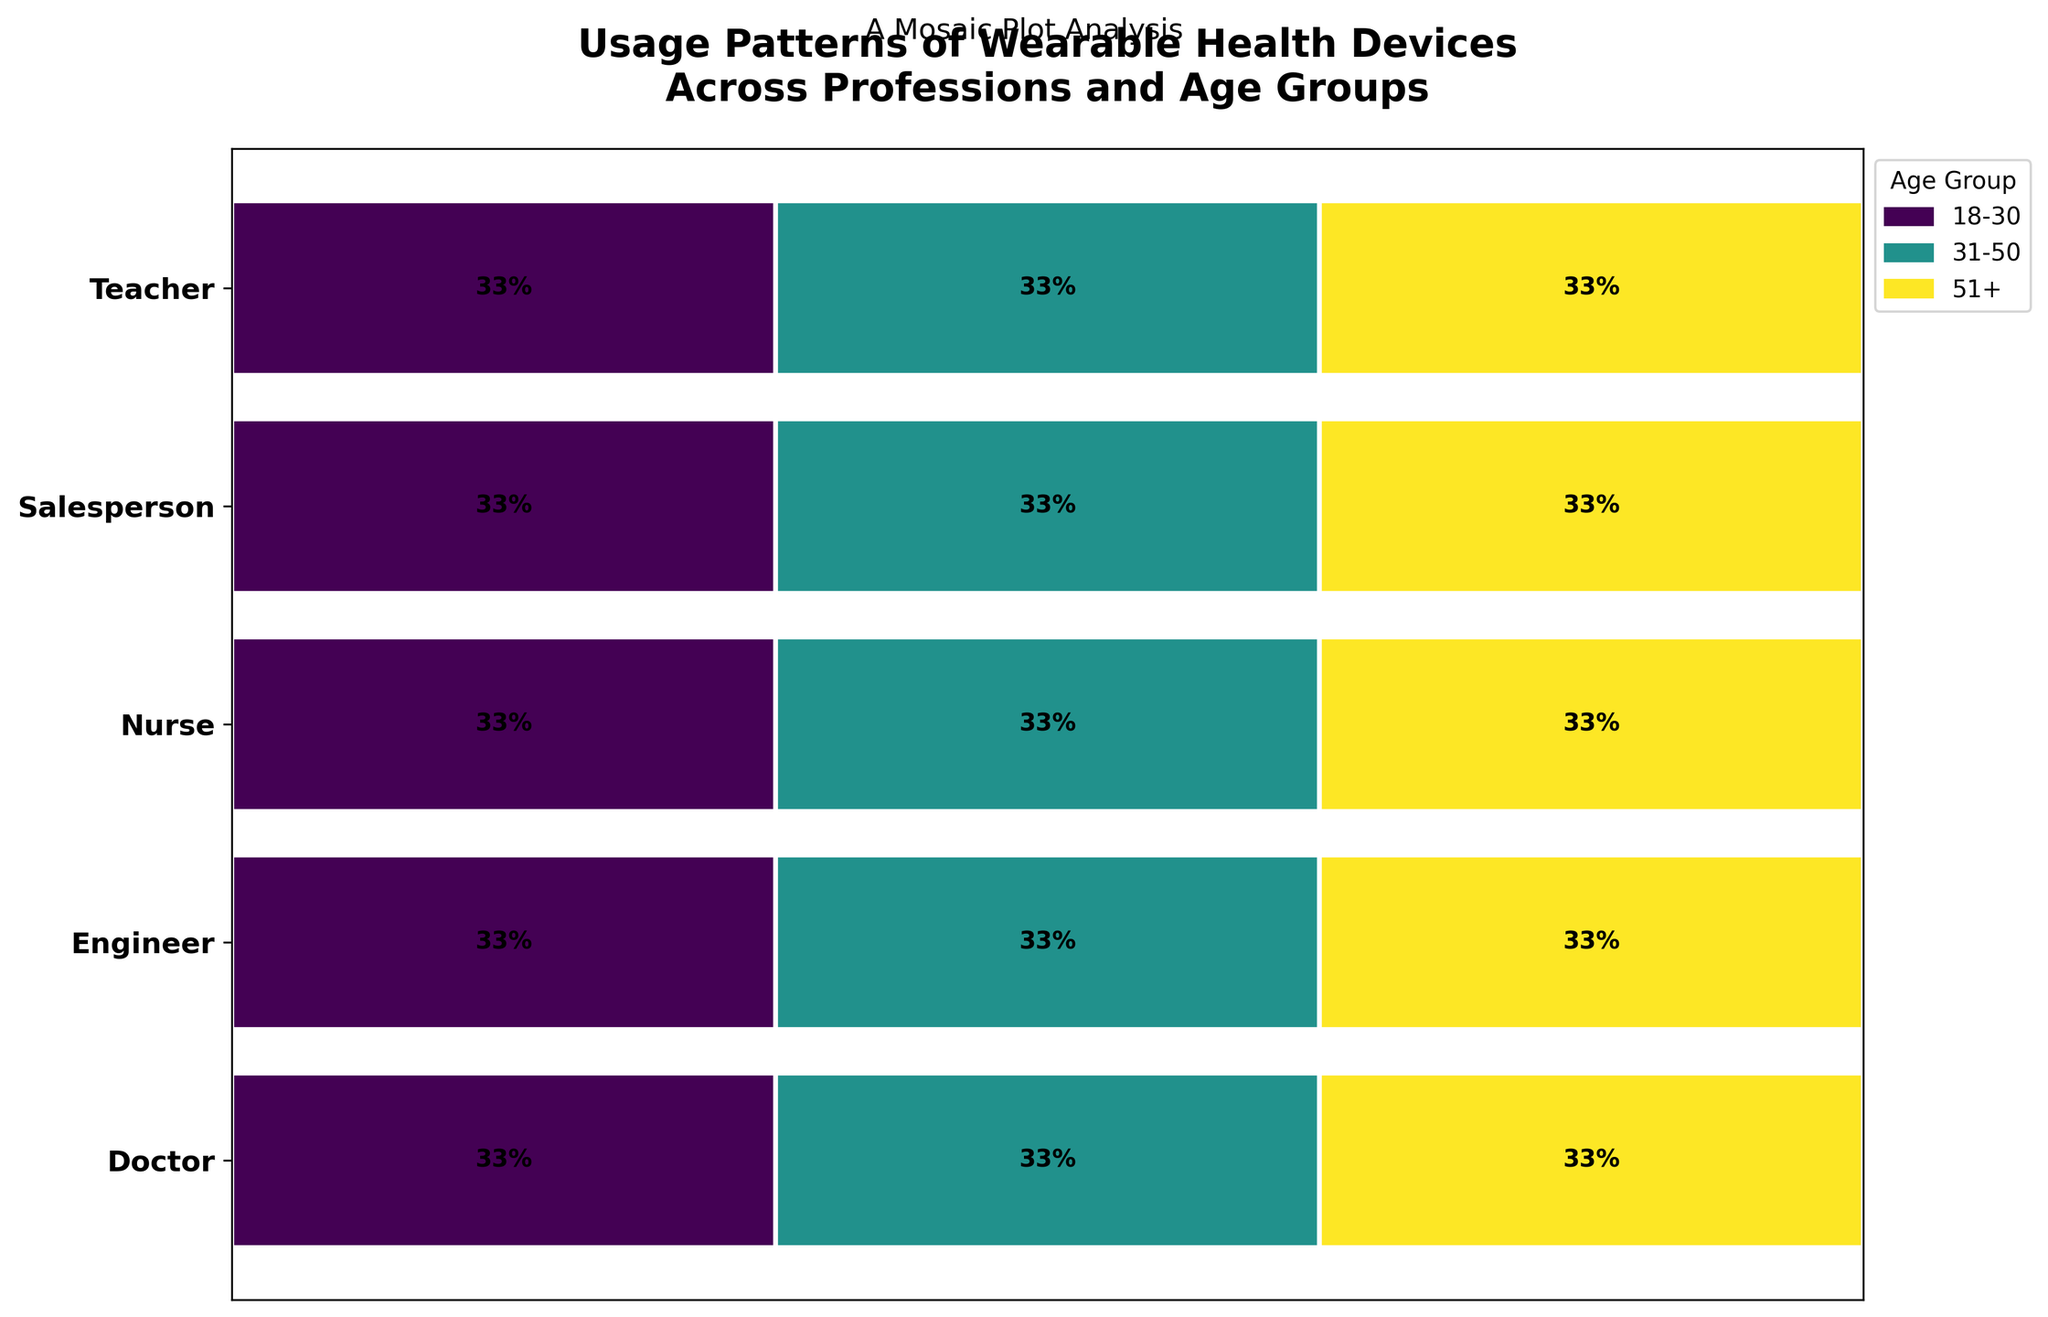What is the title of the plot? The title is usually positioned at the top of the figure and provides a summary of what the data visualization represents. For our plot, the title indicates the subject of the analysis.
Answer: Usage Patterns of Wearable Health Devices Across Professions and Age Groups Which profession has the highest usage in the 18-30 age group? Look at the section corresponding to the 18-30 age group in the mosaic plot and identify which profession has the largest segment.
Answer: Salesperson What percentage of nurses use devices daily across all age groups? Identify the segments labeled with the daily usage across all age groups for nurses and sum up the percentages shown within each group.
Answer: 100% Which age group uses wearable health devices the most in the "Engineer" profession? Compare the relative sizes of the segments for each age group within the "Engineer" profession. The largest segment indicates the age group with the most usage.
Answer: 18-30 Do doctors in the 31-50 age group use wearable devices more or less frequently than teachers in the same age group? Compare the segments for the 31-50 age group for both professions. Assess the frequency based on the label indications.
Answer: Less frequently Which age group shows the most diverse usage patterns across all professions? Assess the differences in segment sizes across all professions within each age group. The age group with the most varied segment sizes shows the most diverse usage patterns.
Answer: 31-50 What proportion of teachers in the 51+ age group use Smartwatches monthly? Look specifically at the segment corresponding to the 51+ age group for teachers and find the percentage labeled as monthly usage.
Answer: 100% How does the use of Blood Pressure Monitors differ between nurses and engineers in the 51+ age group? Examine the 51+ age group segments for both nurses and engineers and compare the relative sizes and frequencies of the Blood Pressure Monitor usage.
Answer: Nurses use them daily, engineers monthly What is the total percentage of daily usage for the 18-30 age group across all professions? Sum the percentages labeled as daily usage for the 18-30 age group across different professions.
Answer: 100% 